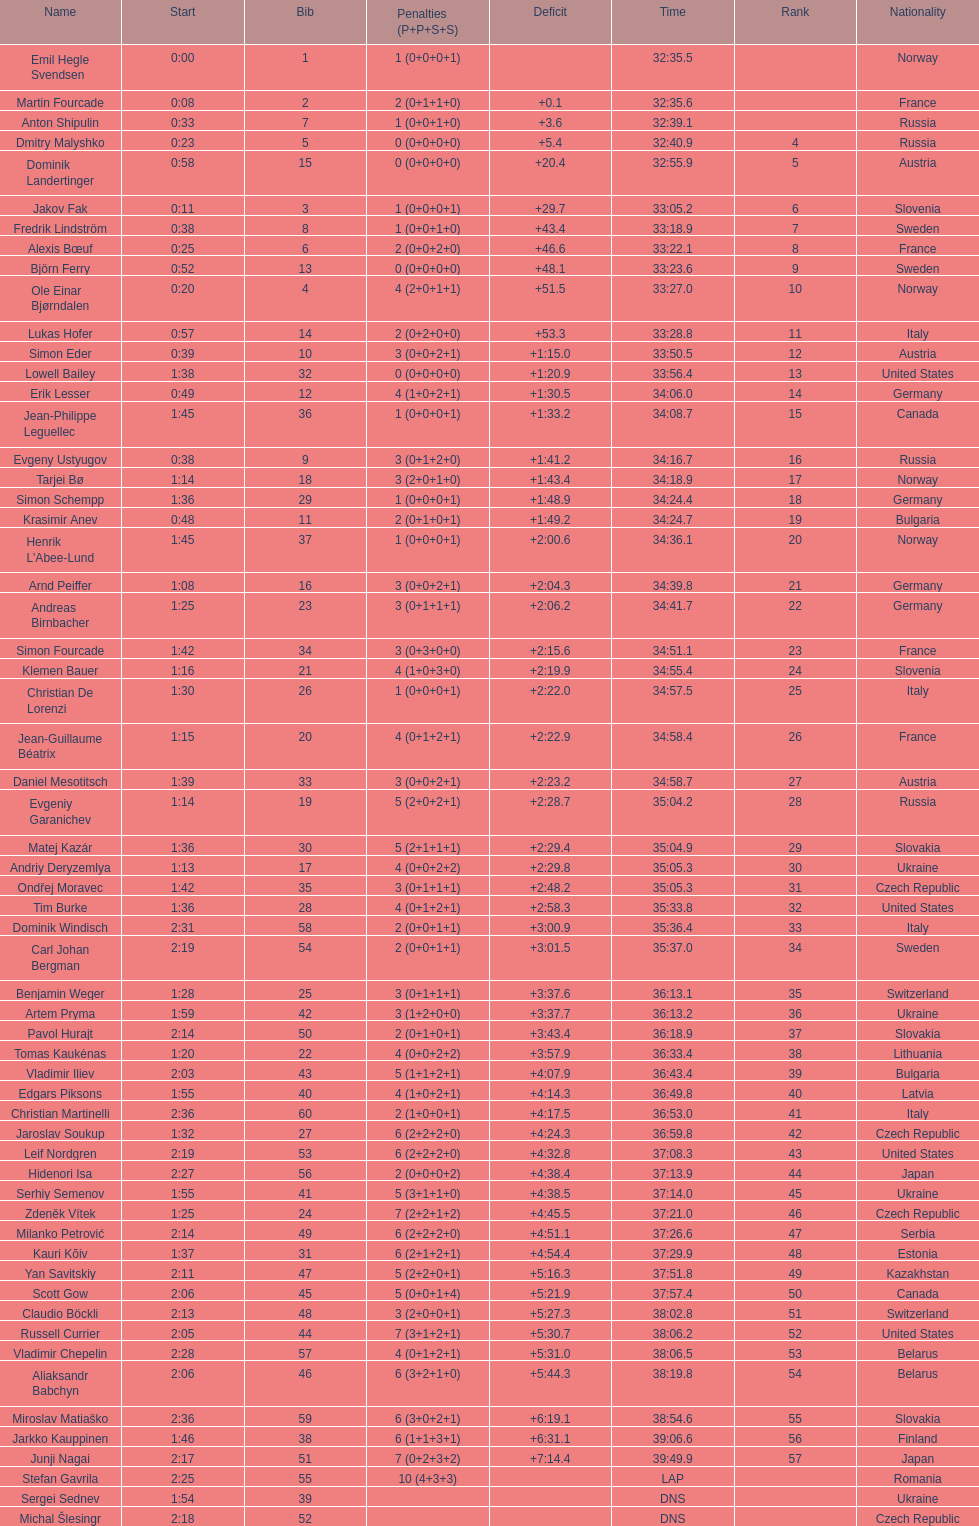How many united states competitors did not win medals? 4. 